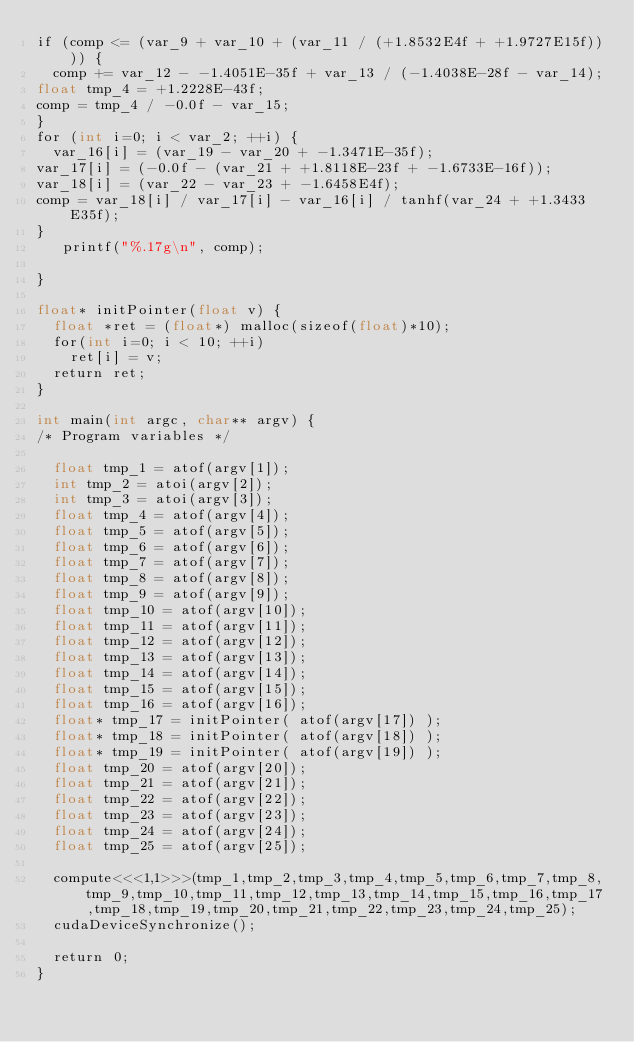<code> <loc_0><loc_0><loc_500><loc_500><_Cuda_>if (comp <= (var_9 + var_10 + (var_11 / (+1.8532E4f + +1.9727E15f)))) {
  comp += var_12 - -1.4051E-35f + var_13 / (-1.4038E-28f - var_14);
float tmp_4 = +1.2228E-43f;
comp = tmp_4 / -0.0f - var_15;
}
for (int i=0; i < var_2; ++i) {
  var_16[i] = (var_19 - var_20 + -1.3471E-35f);
var_17[i] = (-0.0f - (var_21 + +1.8118E-23f + -1.6733E-16f));
var_18[i] = (var_22 - var_23 + -1.6458E4f);
comp = var_18[i] / var_17[i] - var_16[i] / tanhf(var_24 + +1.3433E35f);
}
   printf("%.17g\n", comp);

}

float* initPointer(float v) {
  float *ret = (float*) malloc(sizeof(float)*10);
  for(int i=0; i < 10; ++i)
    ret[i] = v;
  return ret;
}

int main(int argc, char** argv) {
/* Program variables */

  float tmp_1 = atof(argv[1]);
  int tmp_2 = atoi(argv[2]);
  int tmp_3 = atoi(argv[3]);
  float tmp_4 = atof(argv[4]);
  float tmp_5 = atof(argv[5]);
  float tmp_6 = atof(argv[6]);
  float tmp_7 = atof(argv[7]);
  float tmp_8 = atof(argv[8]);
  float tmp_9 = atof(argv[9]);
  float tmp_10 = atof(argv[10]);
  float tmp_11 = atof(argv[11]);
  float tmp_12 = atof(argv[12]);
  float tmp_13 = atof(argv[13]);
  float tmp_14 = atof(argv[14]);
  float tmp_15 = atof(argv[15]);
  float tmp_16 = atof(argv[16]);
  float* tmp_17 = initPointer( atof(argv[17]) );
  float* tmp_18 = initPointer( atof(argv[18]) );
  float* tmp_19 = initPointer( atof(argv[19]) );
  float tmp_20 = atof(argv[20]);
  float tmp_21 = atof(argv[21]);
  float tmp_22 = atof(argv[22]);
  float tmp_23 = atof(argv[23]);
  float tmp_24 = atof(argv[24]);
  float tmp_25 = atof(argv[25]);

  compute<<<1,1>>>(tmp_1,tmp_2,tmp_3,tmp_4,tmp_5,tmp_6,tmp_7,tmp_8,tmp_9,tmp_10,tmp_11,tmp_12,tmp_13,tmp_14,tmp_15,tmp_16,tmp_17,tmp_18,tmp_19,tmp_20,tmp_21,tmp_22,tmp_23,tmp_24,tmp_25);
  cudaDeviceSynchronize();

  return 0;
}
</code> 